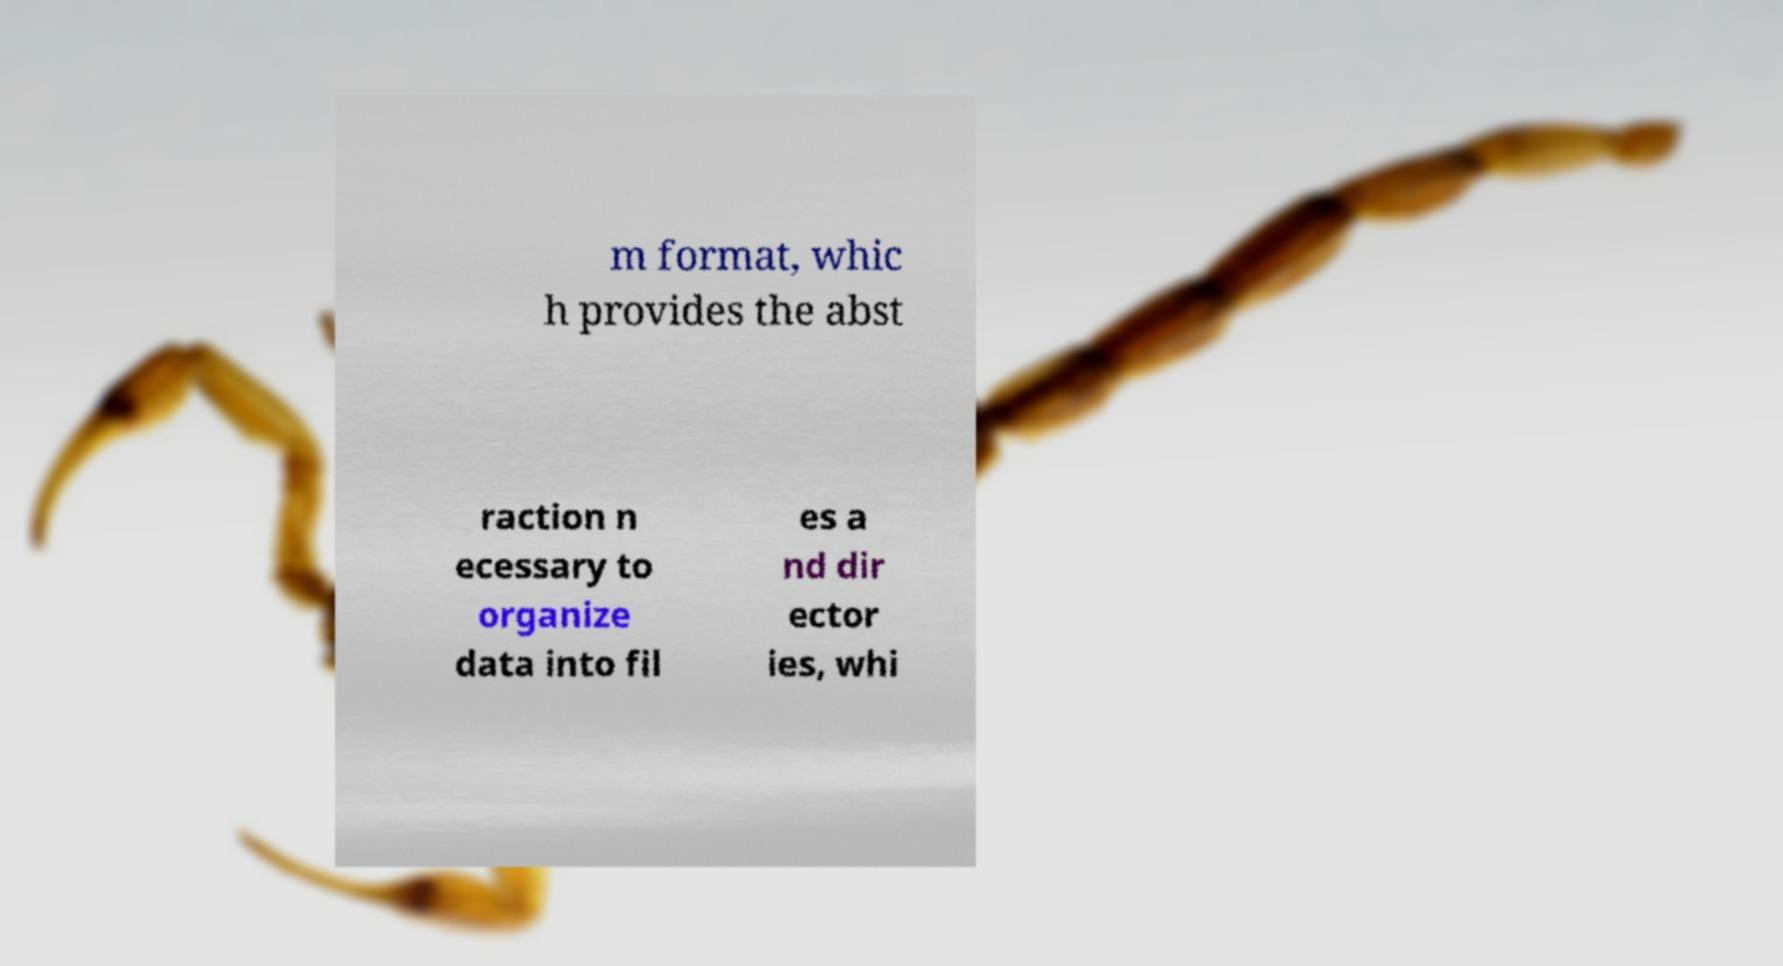Please read and relay the text visible in this image. What does it say? m format, whic h provides the abst raction n ecessary to organize data into fil es a nd dir ector ies, whi 